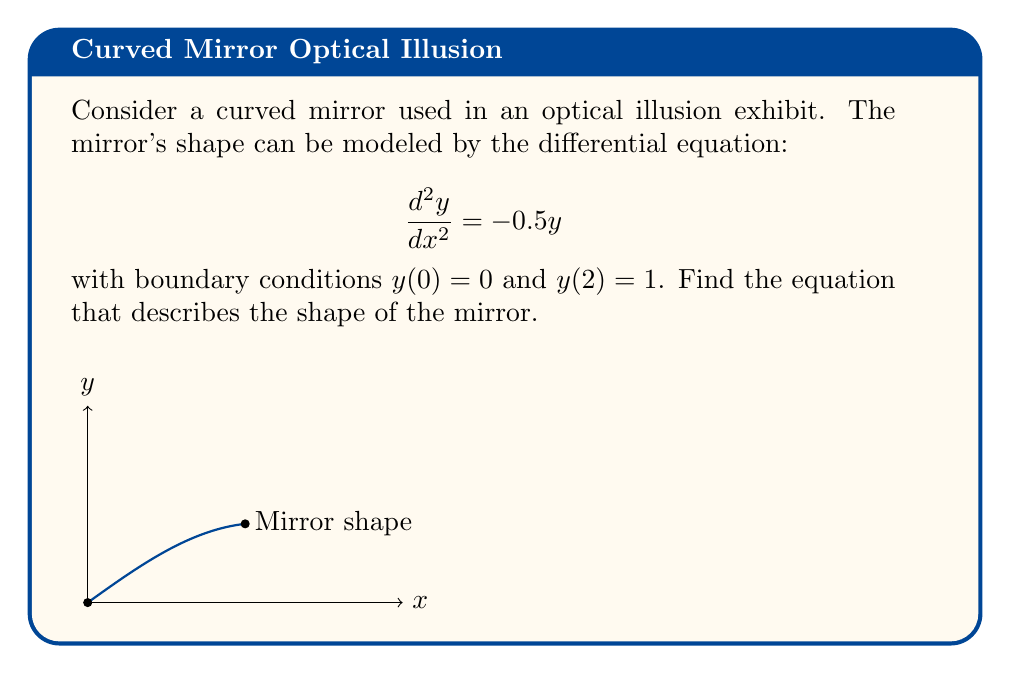Can you solve this math problem? To solve this boundary value problem:

1) The general solution to the differential equation $\frac{d^2y}{dx^2} = -0.5y$ is:
   $$y(x) = A\sin(\frac{\sqrt{2}}{2}x) + B\cos(\frac{\sqrt{2}}{2}x)$$

2) Apply the first boundary condition $y(0) = 0$:
   $$0 = A\sin(0) + B\cos(0) = B$$
   Therefore, $B = 0$

3) The solution becomes:
   $$y(x) = A\sin(\frac{\sqrt{2}}{2}x)$$

4) Apply the second boundary condition $y(2) = 1$:
   $$1 = A\sin(\frac{\sqrt{2}}{2} \cdot 2) = A\sin(\sqrt{2})$$

5) Solve for $A$:
   $$A = \frac{1}{\sin(\sqrt{2})}$$

6) The final solution is:
   $$y(x) = \frac{\sin(\frac{\sqrt{2}}{2}x)}{\sin(\sqrt{2})}$$
Answer: $y(x) = \frac{\sin(\frac{\sqrt{2}}{2}x)}{\sin(\sqrt{2})}$ 